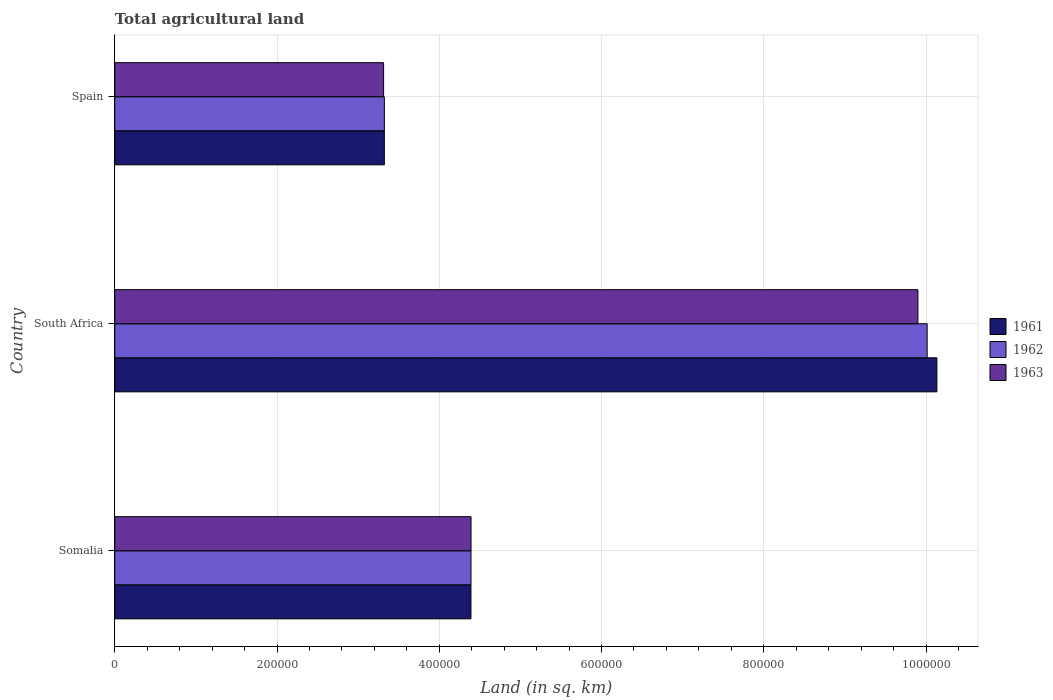How many different coloured bars are there?
Make the answer very short. 3. How many groups of bars are there?
Give a very brief answer. 3. Are the number of bars on each tick of the Y-axis equal?
Make the answer very short. Yes. How many bars are there on the 1st tick from the bottom?
Offer a terse response. 3. What is the label of the 2nd group of bars from the top?
Provide a short and direct response. South Africa. What is the total agricultural land in 1962 in South Africa?
Offer a terse response. 1.00e+06. Across all countries, what is the maximum total agricultural land in 1961?
Offer a very short reply. 1.01e+06. Across all countries, what is the minimum total agricultural land in 1963?
Give a very brief answer. 3.31e+05. In which country was the total agricultural land in 1961 maximum?
Keep it short and to the point. South Africa. In which country was the total agricultural land in 1963 minimum?
Offer a very short reply. Spain. What is the total total agricultural land in 1963 in the graph?
Offer a terse response. 1.76e+06. What is the difference between the total agricultural land in 1962 in Somalia and that in South Africa?
Your answer should be very brief. -5.62e+05. What is the difference between the total agricultural land in 1962 in South Africa and the total agricultural land in 1961 in Somalia?
Ensure brevity in your answer.  5.62e+05. What is the average total agricultural land in 1961 per country?
Your response must be concise. 5.95e+05. What is the difference between the total agricultural land in 1962 and total agricultural land in 1961 in South Africa?
Your answer should be compact. -1.20e+04. What is the ratio of the total agricultural land in 1963 in Somalia to that in South Africa?
Offer a terse response. 0.44. Is the total agricultural land in 1961 in South Africa less than that in Spain?
Provide a short and direct response. No. What is the difference between the highest and the second highest total agricultural land in 1961?
Make the answer very short. 5.74e+05. What is the difference between the highest and the lowest total agricultural land in 1961?
Your response must be concise. 6.81e+05. In how many countries, is the total agricultural land in 1963 greater than the average total agricultural land in 1963 taken over all countries?
Offer a terse response. 1. What does the 3rd bar from the top in Spain represents?
Your answer should be compact. 1961. Is it the case that in every country, the sum of the total agricultural land in 1962 and total agricultural land in 1961 is greater than the total agricultural land in 1963?
Offer a terse response. Yes. Are all the bars in the graph horizontal?
Make the answer very short. Yes. What is the difference between two consecutive major ticks on the X-axis?
Your answer should be compact. 2.00e+05. Does the graph contain any zero values?
Keep it short and to the point. No. Does the graph contain grids?
Make the answer very short. Yes. How many legend labels are there?
Your answer should be compact. 3. How are the legend labels stacked?
Provide a succinct answer. Vertical. What is the title of the graph?
Your answer should be very brief. Total agricultural land. What is the label or title of the X-axis?
Your answer should be very brief. Land (in sq. km). What is the Land (in sq. km) in 1961 in Somalia?
Keep it short and to the point. 4.39e+05. What is the Land (in sq. km) in 1962 in Somalia?
Ensure brevity in your answer.  4.39e+05. What is the Land (in sq. km) of 1963 in Somalia?
Your answer should be compact. 4.39e+05. What is the Land (in sq. km) in 1961 in South Africa?
Offer a terse response. 1.01e+06. What is the Land (in sq. km) in 1962 in South Africa?
Keep it short and to the point. 1.00e+06. What is the Land (in sq. km) in 1963 in South Africa?
Keep it short and to the point. 9.90e+05. What is the Land (in sq. km) of 1961 in Spain?
Provide a short and direct response. 3.32e+05. What is the Land (in sq. km) of 1962 in Spain?
Provide a succinct answer. 3.32e+05. What is the Land (in sq. km) of 1963 in Spain?
Give a very brief answer. 3.31e+05. Across all countries, what is the maximum Land (in sq. km) in 1961?
Your answer should be very brief. 1.01e+06. Across all countries, what is the maximum Land (in sq. km) in 1962?
Your answer should be very brief. 1.00e+06. Across all countries, what is the maximum Land (in sq. km) in 1963?
Provide a succinct answer. 9.90e+05. Across all countries, what is the minimum Land (in sq. km) of 1961?
Give a very brief answer. 3.32e+05. Across all countries, what is the minimum Land (in sq. km) in 1962?
Ensure brevity in your answer.  3.32e+05. Across all countries, what is the minimum Land (in sq. km) in 1963?
Give a very brief answer. 3.31e+05. What is the total Land (in sq. km) in 1961 in the graph?
Provide a succinct answer. 1.78e+06. What is the total Land (in sq. km) of 1962 in the graph?
Ensure brevity in your answer.  1.77e+06. What is the total Land (in sq. km) in 1963 in the graph?
Make the answer very short. 1.76e+06. What is the difference between the Land (in sq. km) of 1961 in Somalia and that in South Africa?
Provide a succinct answer. -5.74e+05. What is the difference between the Land (in sq. km) of 1962 in Somalia and that in South Africa?
Provide a short and direct response. -5.62e+05. What is the difference between the Land (in sq. km) in 1963 in Somalia and that in South Africa?
Your response must be concise. -5.51e+05. What is the difference between the Land (in sq. km) of 1961 in Somalia and that in Spain?
Offer a very short reply. 1.07e+05. What is the difference between the Land (in sq. km) of 1962 in Somalia and that in Spain?
Offer a terse response. 1.07e+05. What is the difference between the Land (in sq. km) in 1963 in Somalia and that in Spain?
Offer a very short reply. 1.08e+05. What is the difference between the Land (in sq. km) of 1961 in South Africa and that in Spain?
Provide a succinct answer. 6.81e+05. What is the difference between the Land (in sq. km) in 1962 in South Africa and that in Spain?
Offer a terse response. 6.69e+05. What is the difference between the Land (in sq. km) of 1963 in South Africa and that in Spain?
Offer a terse response. 6.59e+05. What is the difference between the Land (in sq. km) of 1961 in Somalia and the Land (in sq. km) of 1962 in South Africa?
Give a very brief answer. -5.62e+05. What is the difference between the Land (in sq. km) of 1961 in Somalia and the Land (in sq. km) of 1963 in South Africa?
Offer a very short reply. -5.51e+05. What is the difference between the Land (in sq. km) of 1962 in Somalia and the Land (in sq. km) of 1963 in South Africa?
Make the answer very short. -5.51e+05. What is the difference between the Land (in sq. km) in 1961 in Somalia and the Land (in sq. km) in 1962 in Spain?
Ensure brevity in your answer.  1.07e+05. What is the difference between the Land (in sq. km) in 1961 in Somalia and the Land (in sq. km) in 1963 in Spain?
Keep it short and to the point. 1.08e+05. What is the difference between the Land (in sq. km) in 1962 in Somalia and the Land (in sq. km) in 1963 in Spain?
Provide a short and direct response. 1.08e+05. What is the difference between the Land (in sq. km) in 1961 in South Africa and the Land (in sq. km) in 1962 in Spain?
Keep it short and to the point. 6.81e+05. What is the difference between the Land (in sq. km) of 1961 in South Africa and the Land (in sq. km) of 1963 in Spain?
Your answer should be very brief. 6.82e+05. What is the difference between the Land (in sq. km) of 1962 in South Africa and the Land (in sq. km) of 1963 in Spain?
Keep it short and to the point. 6.70e+05. What is the average Land (in sq. km) in 1961 per country?
Provide a short and direct response. 5.95e+05. What is the average Land (in sq. km) of 1962 per country?
Your answer should be very brief. 5.91e+05. What is the average Land (in sq. km) of 1963 per country?
Offer a terse response. 5.87e+05. What is the difference between the Land (in sq. km) in 1961 and Land (in sq. km) in 1963 in Somalia?
Your answer should be compact. -100. What is the difference between the Land (in sq. km) in 1961 and Land (in sq. km) in 1962 in South Africa?
Give a very brief answer. 1.20e+04. What is the difference between the Land (in sq. km) of 1961 and Land (in sq. km) of 1963 in South Africa?
Provide a short and direct response. 2.34e+04. What is the difference between the Land (in sq. km) in 1962 and Land (in sq. km) in 1963 in South Africa?
Offer a very short reply. 1.14e+04. What is the difference between the Land (in sq. km) of 1961 and Land (in sq. km) of 1962 in Spain?
Keep it short and to the point. -20. What is the difference between the Land (in sq. km) in 1961 and Land (in sq. km) in 1963 in Spain?
Ensure brevity in your answer.  930. What is the difference between the Land (in sq. km) of 1962 and Land (in sq. km) of 1963 in Spain?
Your answer should be very brief. 950. What is the ratio of the Land (in sq. km) of 1961 in Somalia to that in South Africa?
Offer a very short reply. 0.43. What is the ratio of the Land (in sq. km) of 1962 in Somalia to that in South Africa?
Offer a very short reply. 0.44. What is the ratio of the Land (in sq. km) of 1963 in Somalia to that in South Africa?
Provide a short and direct response. 0.44. What is the ratio of the Land (in sq. km) of 1961 in Somalia to that in Spain?
Your answer should be compact. 1.32. What is the ratio of the Land (in sq. km) of 1962 in Somalia to that in Spain?
Make the answer very short. 1.32. What is the ratio of the Land (in sq. km) in 1963 in Somalia to that in Spain?
Provide a short and direct response. 1.33. What is the ratio of the Land (in sq. km) in 1961 in South Africa to that in Spain?
Your answer should be compact. 3.05. What is the ratio of the Land (in sq. km) of 1962 in South Africa to that in Spain?
Provide a succinct answer. 3.01. What is the ratio of the Land (in sq. km) in 1963 in South Africa to that in Spain?
Offer a terse response. 2.99. What is the difference between the highest and the second highest Land (in sq. km) of 1961?
Provide a short and direct response. 5.74e+05. What is the difference between the highest and the second highest Land (in sq. km) in 1962?
Offer a terse response. 5.62e+05. What is the difference between the highest and the second highest Land (in sq. km) of 1963?
Keep it short and to the point. 5.51e+05. What is the difference between the highest and the lowest Land (in sq. km) of 1961?
Your response must be concise. 6.81e+05. What is the difference between the highest and the lowest Land (in sq. km) in 1962?
Offer a very short reply. 6.69e+05. What is the difference between the highest and the lowest Land (in sq. km) of 1963?
Your answer should be very brief. 6.59e+05. 